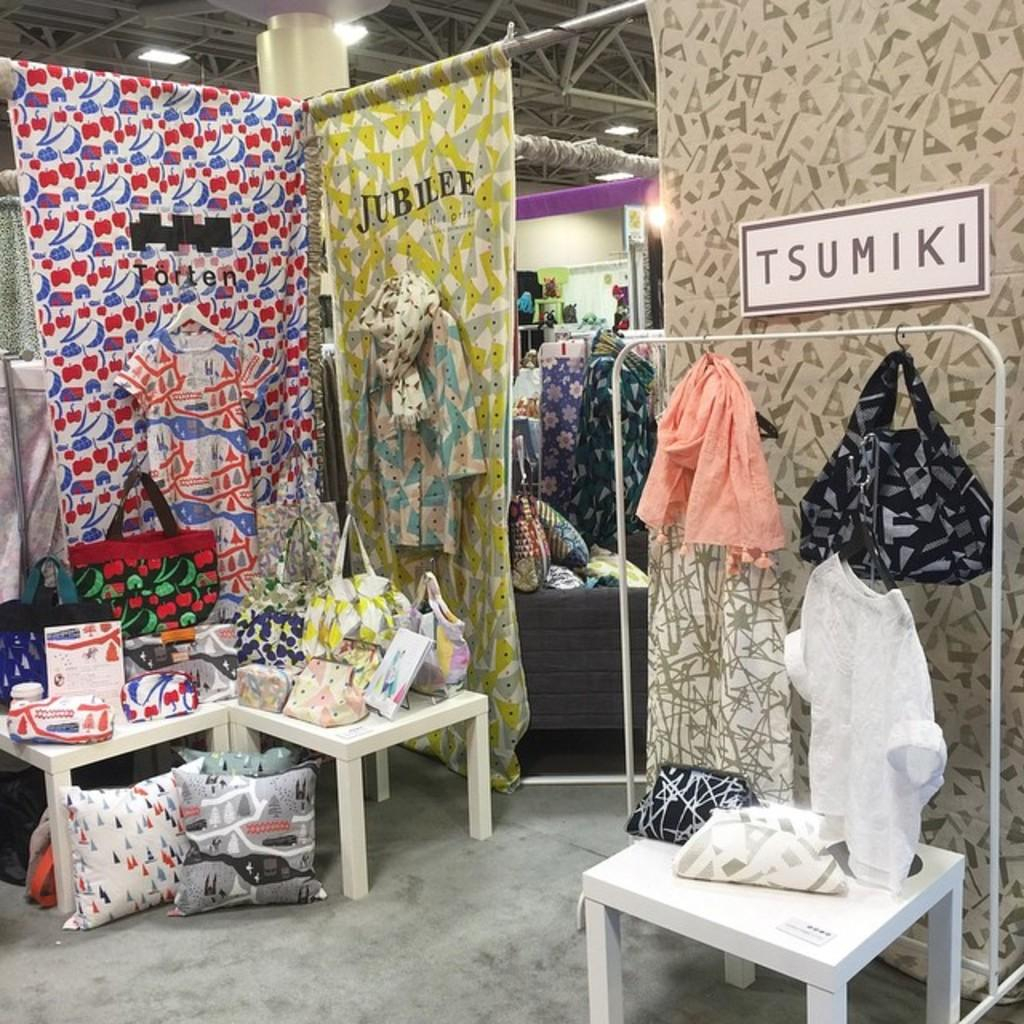Where was the image taken? The image was taken inside a building. What can be seen in the image that is used for covering windows? There are many curtains in the image. What is being used to hang clothes in the image? Clothes are hanged on a stand to the right. What items are placed near tables in the image? Pillows are kept near tables to the left. What type of mist can be seen outside the building in the image? There is no mist visible in the image, as it was taken inside a building. 